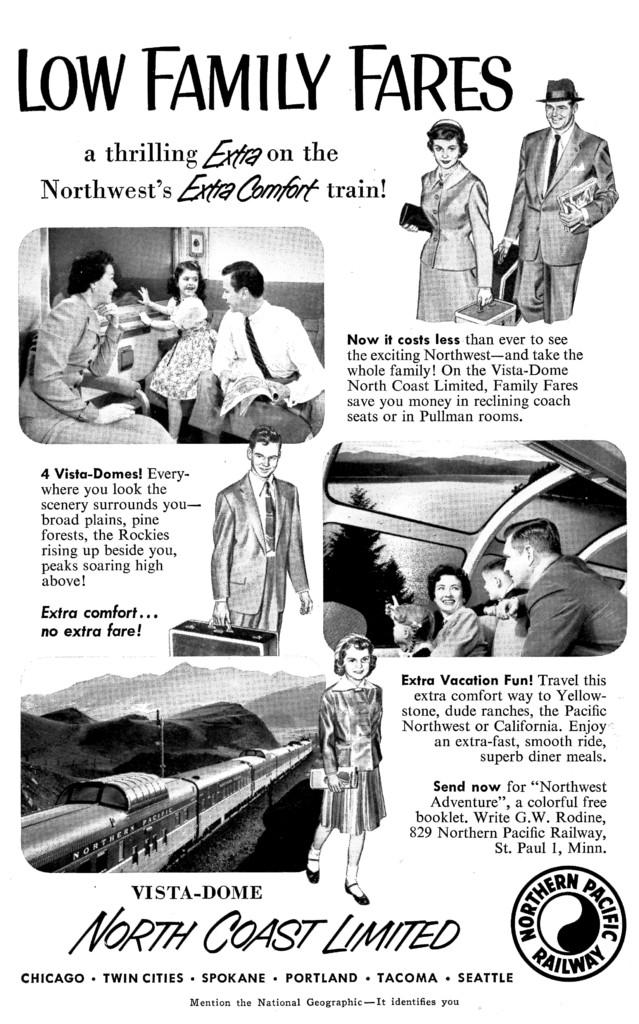What is the main subject of the printed photo in the image? The photo contains a train. What other elements can be seen in the photo? There is a hill, a tree, and a lake visible in the photo. Is there any text present in the photo? Yes, the photo contains text. Can you identify any logos in the photo? Yes, there is a logo visible in the photo. What type of bun is being served to the manager in the image? There is no image of a manager or a bun present in the provided facts. 